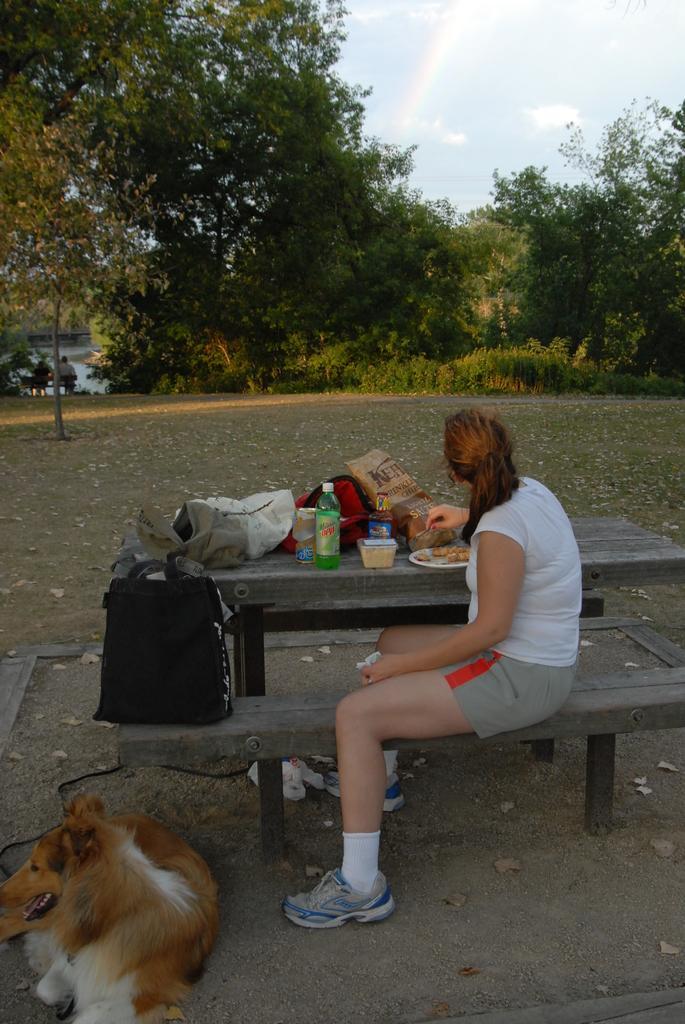Describe this image in one or two sentences. Person sitting on the bench on the table we have bottle,plate,food,bag and in the background we have trees and in front dog is sitting. 